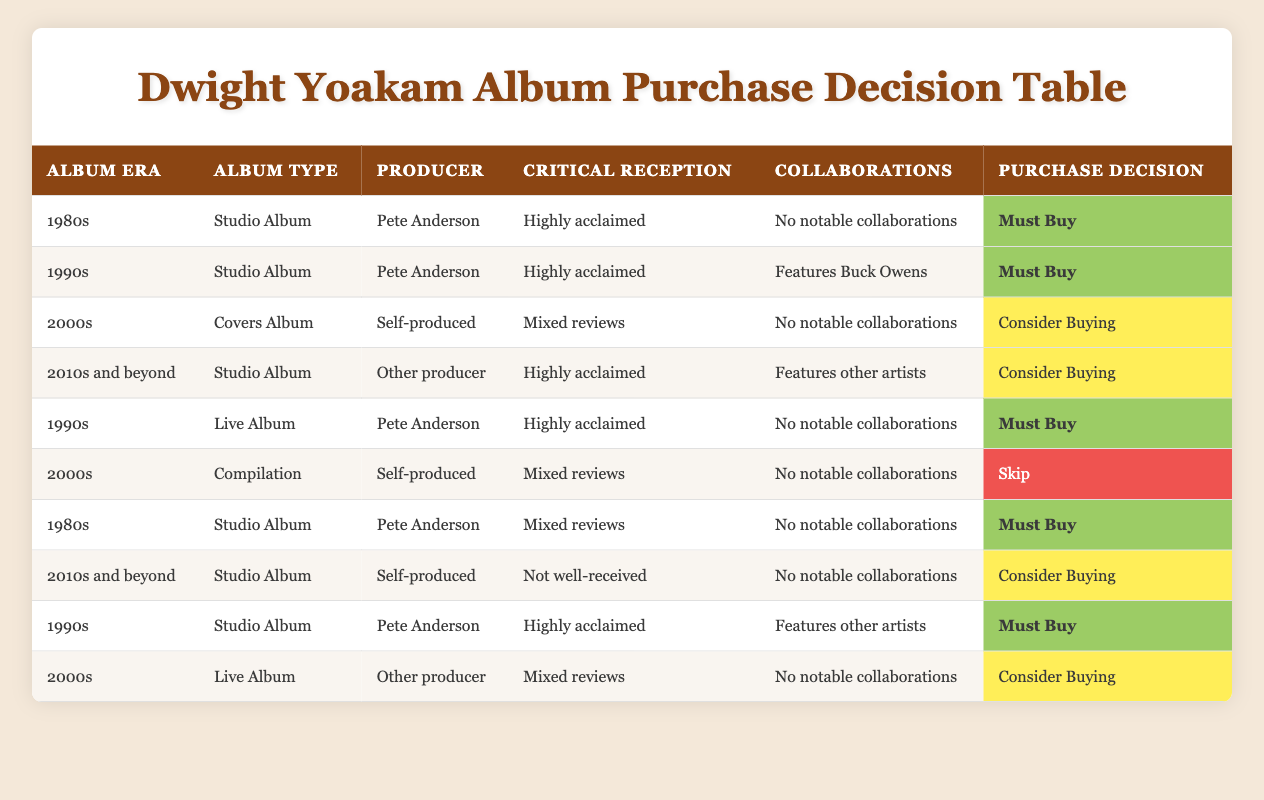What purchase decision is indicated for a studio album from the 1980s produced by Pete Anderson with highly acclaimed critical reception and no notable collaborations? The table shows that under the specified conditions, the action taken is "Must Buy", as it appears in a row that reflects those conditions accurately.
Answer: Must Buy How many albums from the 1990s are categorized as "Must Buy"? The table lists three rows with the 1990s era where the purchase decision is "Must Buy" for studio albums produced by Pete Anderson, both with highly acclaimed reviews and one featuring Buck Owens.
Answer: 3 Is there a live album from the 1990s that is highly acclaimed and has no notable collaborations? Yes, the table presents a row for the 1990s that indicates a live album produced by Pete Anderson, which has a "Must Buy" decision based on the conditions specified.
Answer: Yes What is the purchase decision for a compilation album from the 2000s that was self-produced and received mixed reviews? The table contains a row that describes such an album as having a decision to "Skip", indicating it is not a recommended purchase based on the criteria.
Answer: Skip Which producer is associated with the most "Must Buy" albums, and how many are there? By reviewing the table, we see that albums produced by Pete Anderson in the 1980s and 1990s fit the "Must Buy" category, totaling five instances across different records.
Answer: Pete Anderson, 5 How does the purchase decision for live albums in the 2000s compare to those from the 1990s? The table shows that live albums from the 1990s, particularly those produced by Pete Anderson, lead to a "Must Buy" decision, while live albums from the 2000s with mixed reviews produced by other producers only suggest "Consider Buying".
Answer: 1990s - Must Buy; 2000s - Consider Buying What is the average purchase decision rating for albums from the 2010s and beyond? The table indicates two purchase decisions for the 2010s (Consider Buying and Consider Buying), which when averaged categorically gives a consistent recommendation of "Consider Buying" since both share this verdict.
Answer: Consider Buying Are there any "Covers Albums" from the 2000s recommended for purchase? No, the table clearly indicates that the only Covers Album from the 2000s produced by self is suggested as "Consider Buying", hence not strongly endorsed as a purchase.
Answer: No 